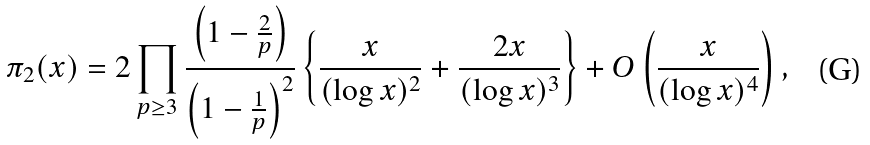<formula> <loc_0><loc_0><loc_500><loc_500>\pi _ { 2 } ( x ) = 2 \prod _ { p \geq 3 } \frac { \left ( 1 - \frac { 2 } { p } \right ) } { \left ( 1 - \frac { 1 } { p } \right ) ^ { 2 } } \left \{ \frac { x } { ( \log x ) ^ { 2 } } + \frac { 2 x } { ( \log x ) ^ { 3 } } \right \} + O \left ( \frac { x } { ( \log x ) ^ { 4 } } \right ) ,</formula> 